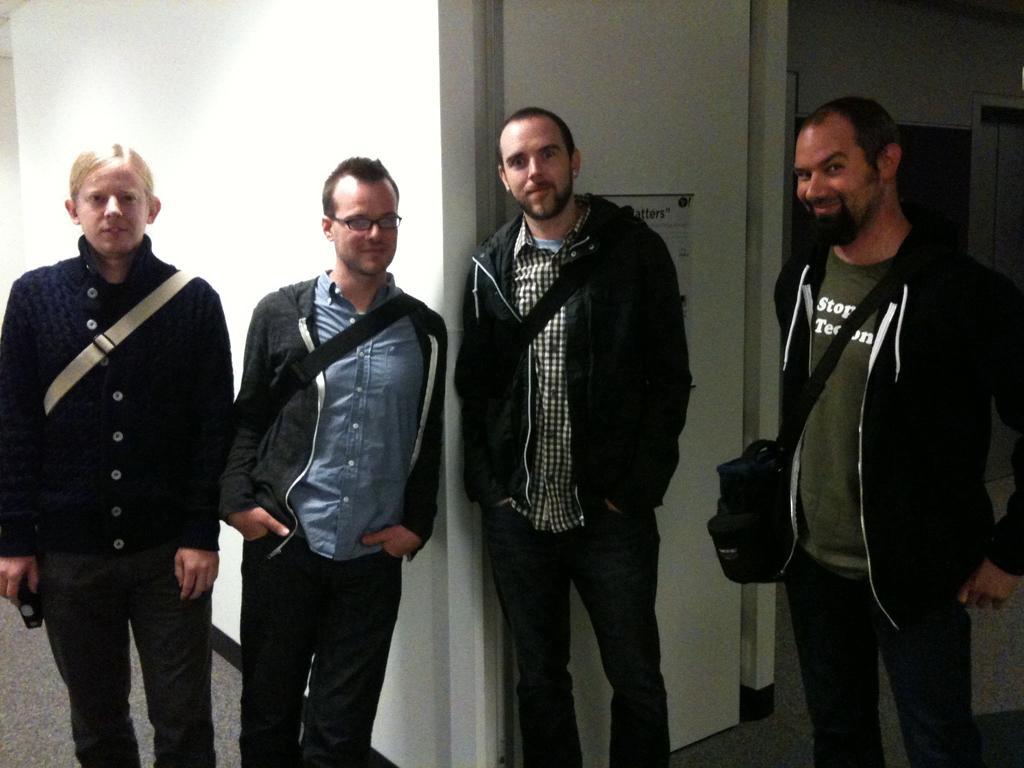In one or two sentences, can you explain what this image depicts? In the image we see 4 men standing in front and one of them is wearing spectacles and we see that everyone are smiling. In the background there is a white wall. 